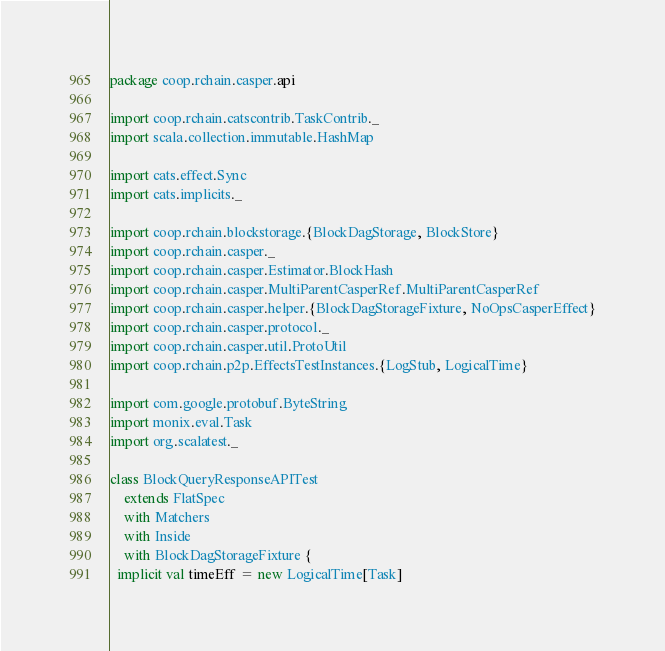Convert code to text. <code><loc_0><loc_0><loc_500><loc_500><_Scala_>package coop.rchain.casper.api

import coop.rchain.catscontrib.TaskContrib._
import scala.collection.immutable.HashMap

import cats.effect.Sync
import cats.implicits._

import coop.rchain.blockstorage.{BlockDagStorage, BlockStore}
import coop.rchain.casper._
import coop.rchain.casper.Estimator.BlockHash
import coop.rchain.casper.MultiParentCasperRef.MultiParentCasperRef
import coop.rchain.casper.helper.{BlockDagStorageFixture, NoOpsCasperEffect}
import coop.rchain.casper.protocol._
import coop.rchain.casper.util.ProtoUtil
import coop.rchain.p2p.EffectsTestInstances.{LogStub, LogicalTime}

import com.google.protobuf.ByteString
import monix.eval.Task
import org.scalatest._

class BlockQueryResponseAPITest
    extends FlatSpec
    with Matchers
    with Inside
    with BlockDagStorageFixture {
  implicit val timeEff = new LogicalTime[Task]</code> 